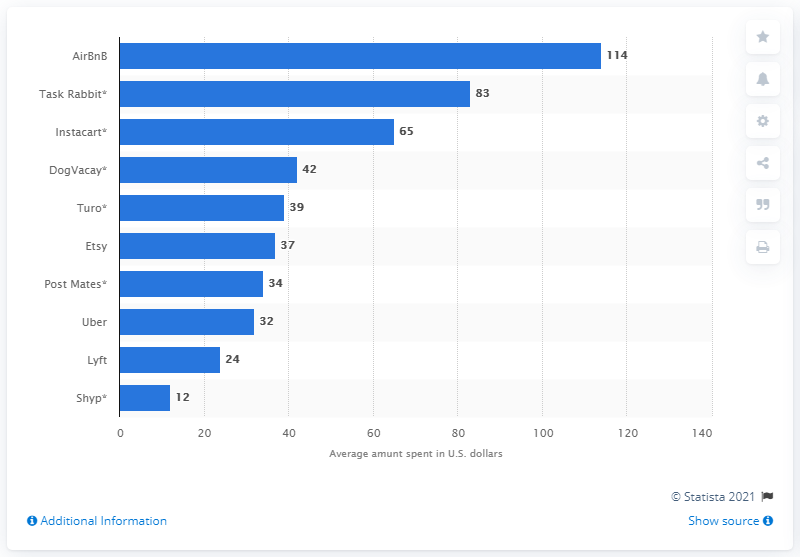Give some essential details in this illustration. Airbnb users on average spent $114 dollars. 